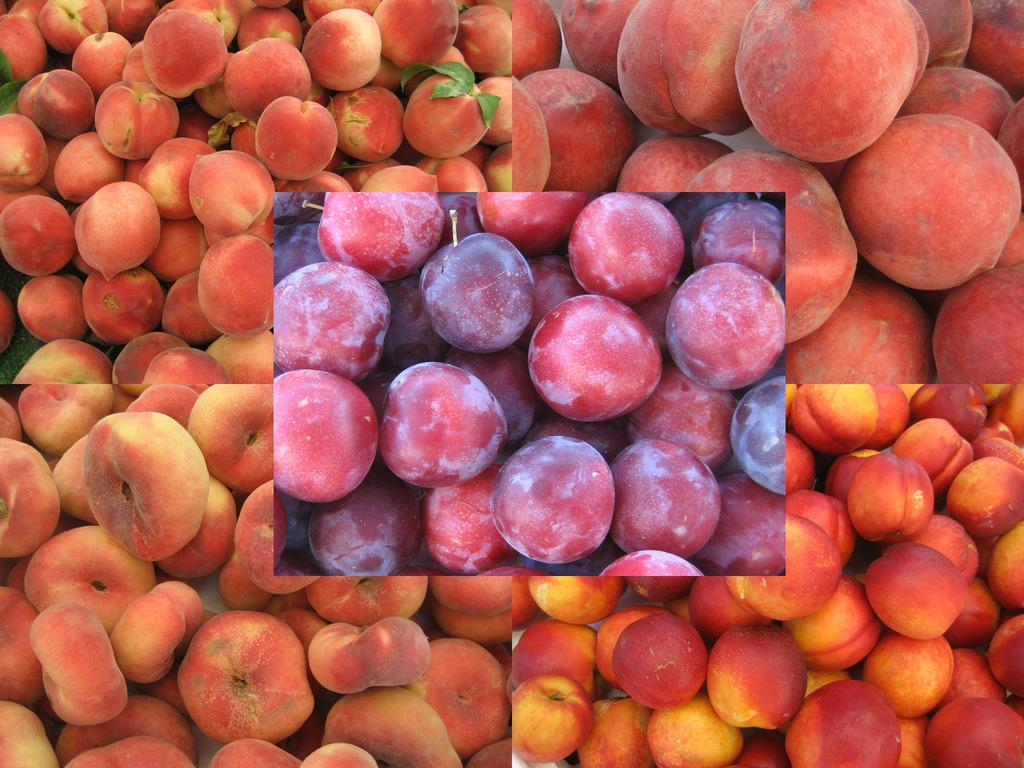What type of images are present in the collage? The collage contains images of fruits. Can you describe the arrangement of the fruits in the collage? The arrangement of the fruits in the collage cannot be determined from the provided facts. What colors are predominant in the collage? The predominant colors in the collage depend on the specific fruits depicted, but they are likely to include various shades of red, orange, yellow, green, and purple. What type of noise can be heard coming from the fruits in the image? There is no noise present in the image, as it is a static collage of fruits. 